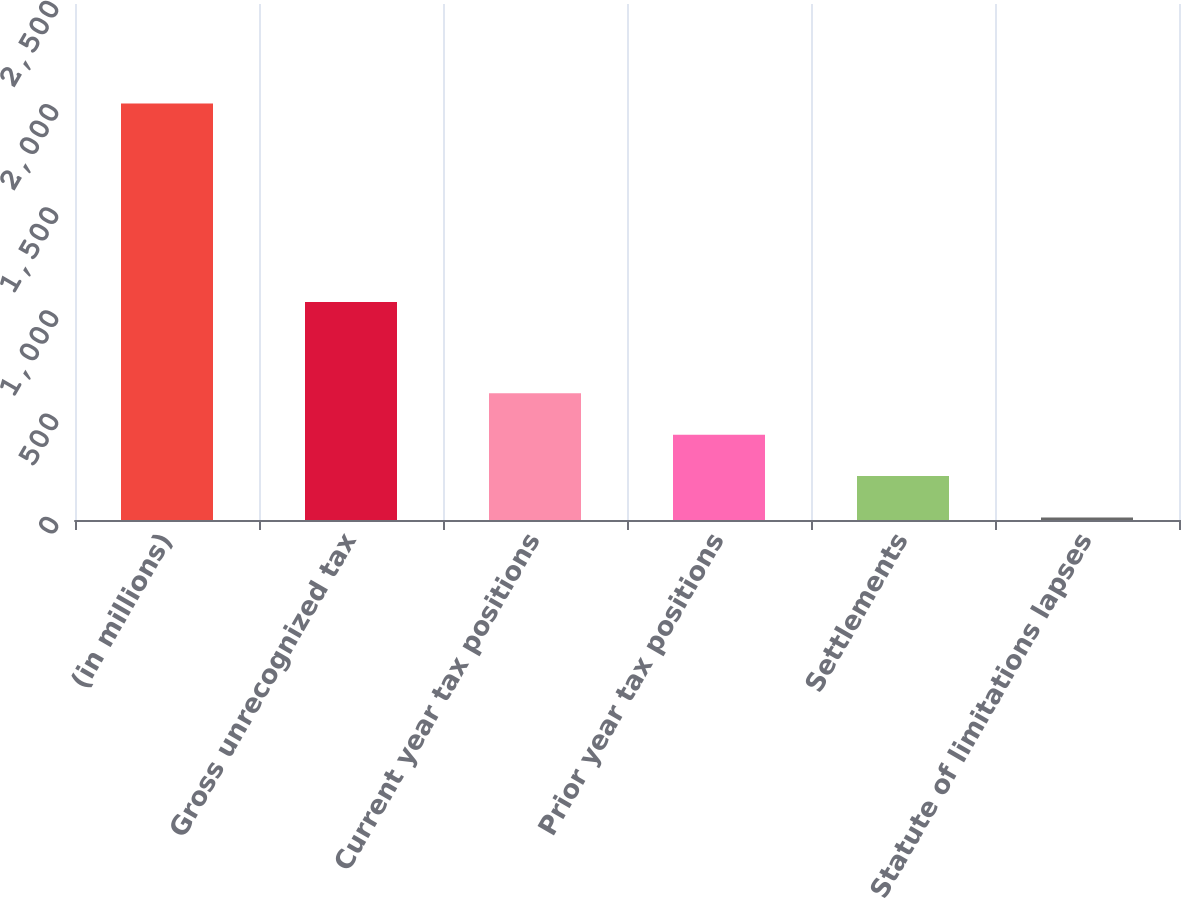<chart> <loc_0><loc_0><loc_500><loc_500><bar_chart><fcel>(in millions)<fcel>Gross unrecognized tax<fcel>Current year tax positions<fcel>Prior year tax positions<fcel>Settlements<fcel>Statute of limitations lapses<nl><fcel>2018<fcel>1056<fcel>613.8<fcel>413.2<fcel>212.6<fcel>12<nl></chart> 